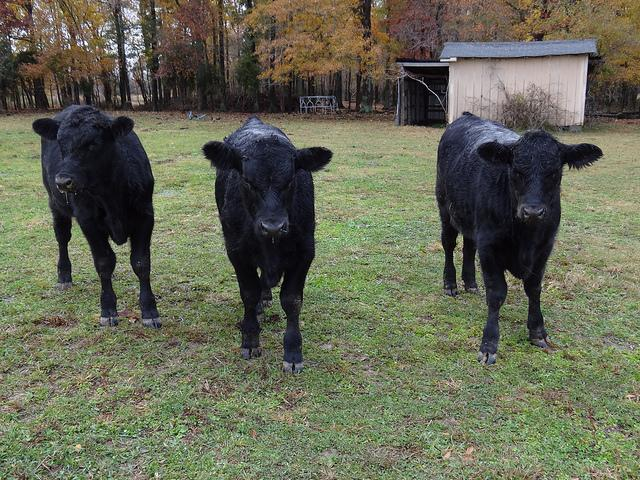How many cows are standing in the pasture field? three 